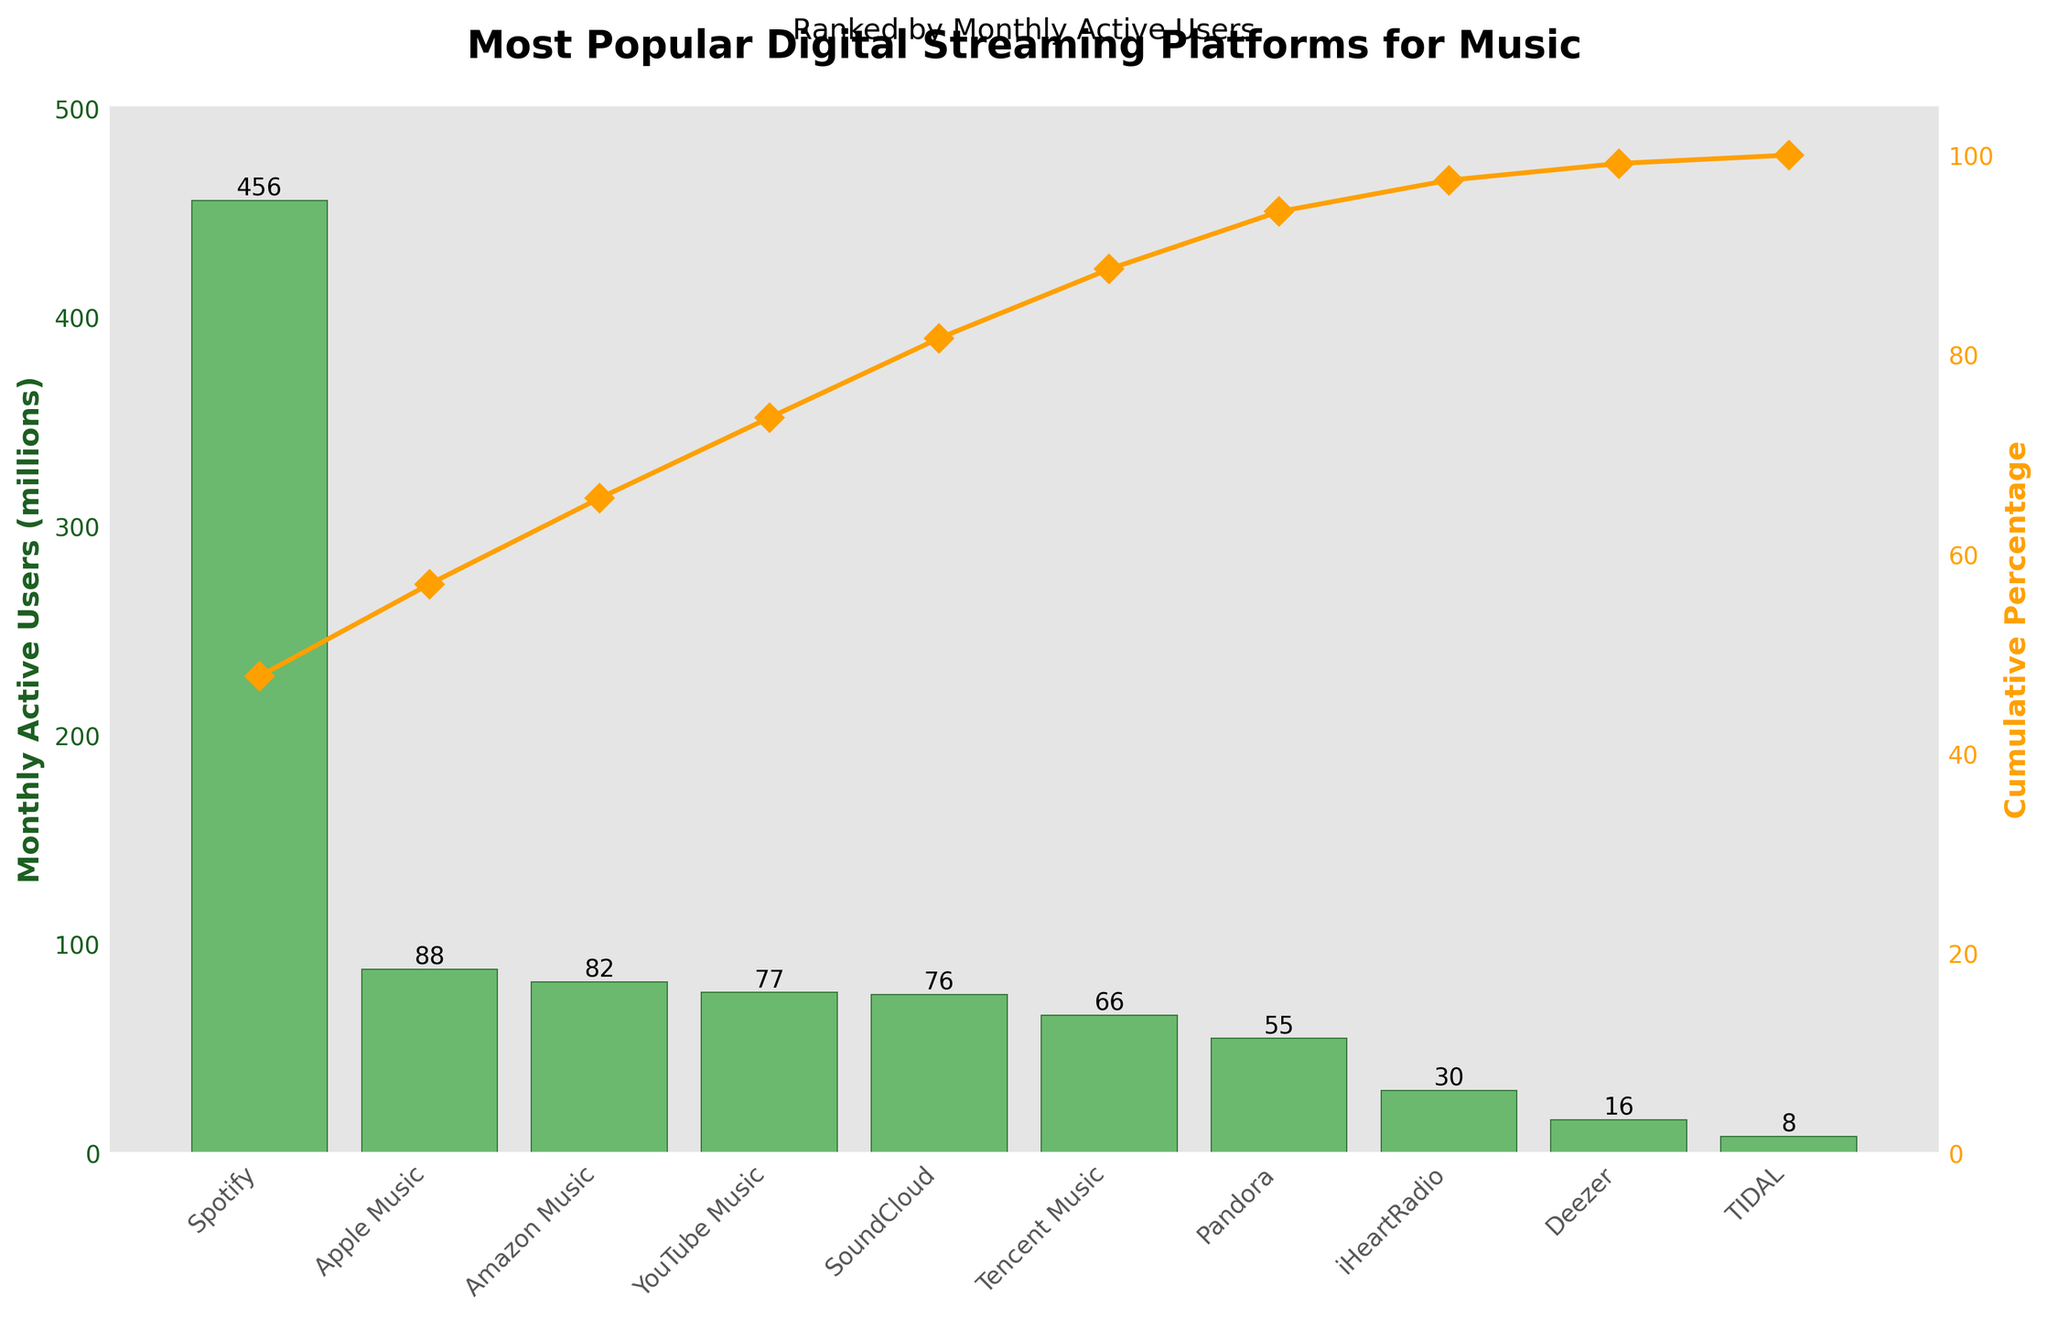What is the platform with the highest number of monthly active users? The platform with the highest number of monthly active users can be identified by looking at the tallest bar in the bar chart. In the chart, Spotify has the highest bar.
Answer: Spotify What is the total number of platforms listed? The number of platforms listed is equivalent to the number of bars in the bar chart. Counting the bars shows there are ten platforms.
Answer: 10 Which platform has a higher number of monthly active users: Amazon Music or SoundCloud? To answer this, compare the height of the bars representing Amazon Music and SoundCloud. Amazon Music has a shorter bar than SoundCloud, indicating fewer users.
Answer: SoundCloud What is the cumulative percentage for Apple Music? The cumulative percentage for Apple Music is shown by the line chart where it intersects vertically above Apple Music. The value can be read directly from the y-axis on the right side.
Answer: Approximately 62.3% How many platforms have more than 50 million monthly active users? To find this, count the number of bars that extend above the 50 million mark on the y-axis. The platforms are Spotify, Apple Music, Amazon Music, YouTube Music, Pandora, and SoundCloud, making a total of six.
Answer: 6 What is the difference in monthly active users between Spotify and Pandora? Subtract the number of monthly active users of Pandora from Spotify by referring to the height of their bars. That is, 456 million minus 55 million.
Answer: 401 million What's the cumulative percentage of monthly active users for all platforms combined except Spotify? Exclude Spotify's value from the total and calculate the cumulative percentage of the remaining platforms by summing their values, then dividing by the total and multiplying by 100. Total excluding Spotify is 498 million out of a total of 954 million. So, 498 / 954 * 100.
Answer: Approximately 52.2% Which platform is second in terms of monthly active users? Based on the bar heights, the second tallest bar represents Apple Music.
Answer: Apple Music 